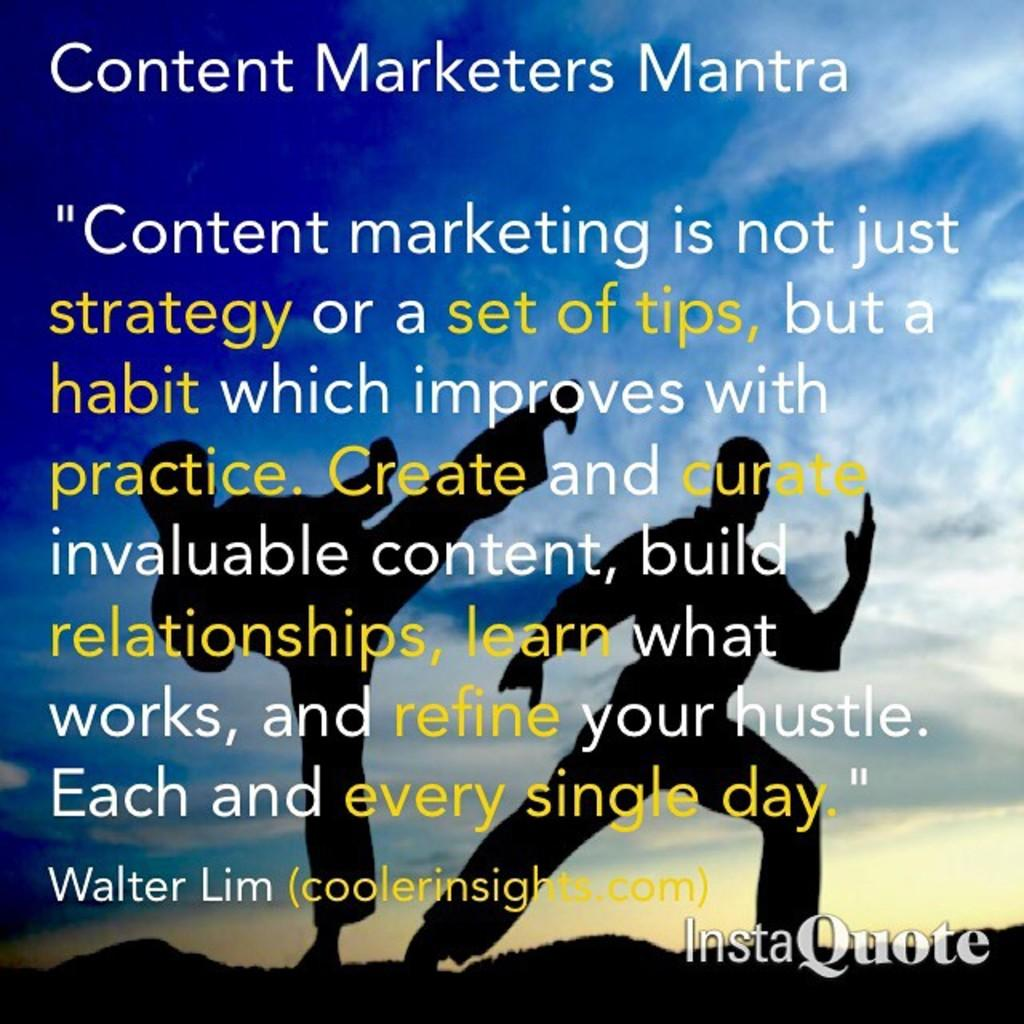<image>
Provide a brief description of the given image. An inspirational poster that is titled Content Marketers Mantra. 